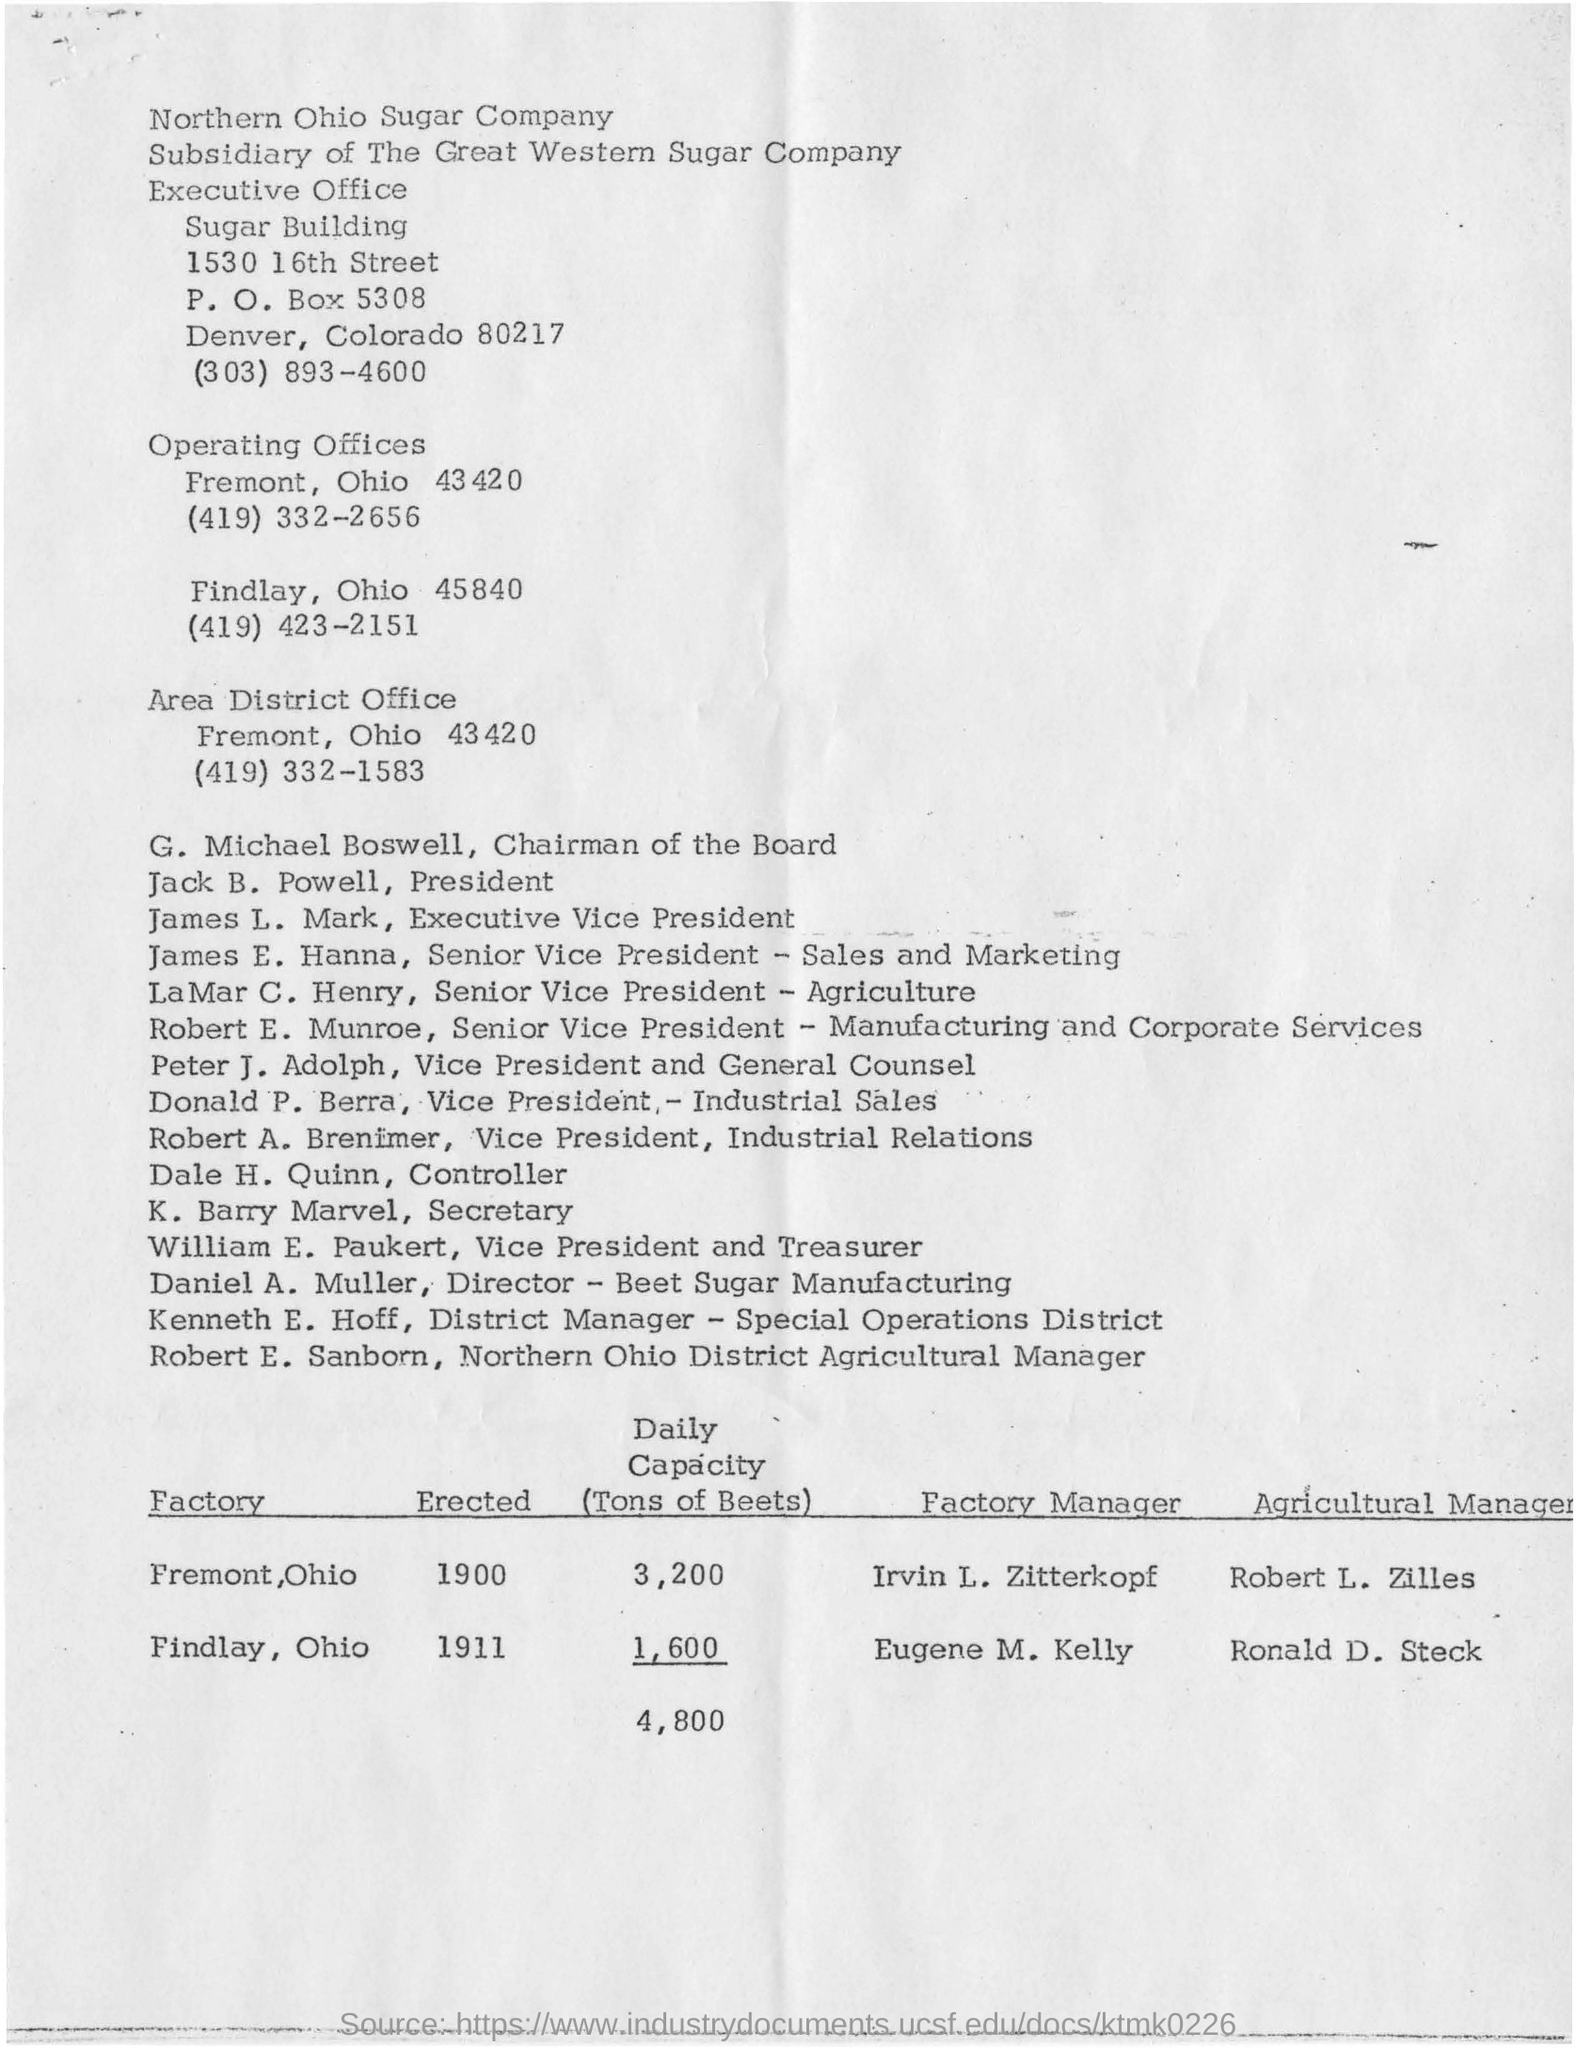Draw attention to some important aspects in this diagram. The contact number for the executive sugar building is (303) 893-4600. The total daily capacity of beets from both Fremont and Findlay factories is 4,800 tons. The designated chairman of the board is G. Michael Boswell. The contact number for the area district office is (419) 332-1583. The location of operating offices is Fremont, Ohio, which is located at 43420. 